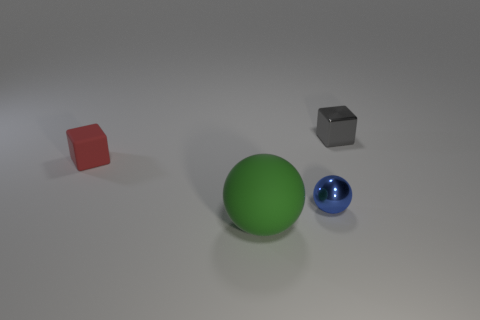Add 3 tiny gray things. How many objects exist? 7 Subtract all tiny cyan objects. Subtract all balls. How many objects are left? 2 Add 3 balls. How many balls are left? 5 Add 3 big yellow blocks. How many big yellow blocks exist? 3 Subtract 0 purple cylinders. How many objects are left? 4 